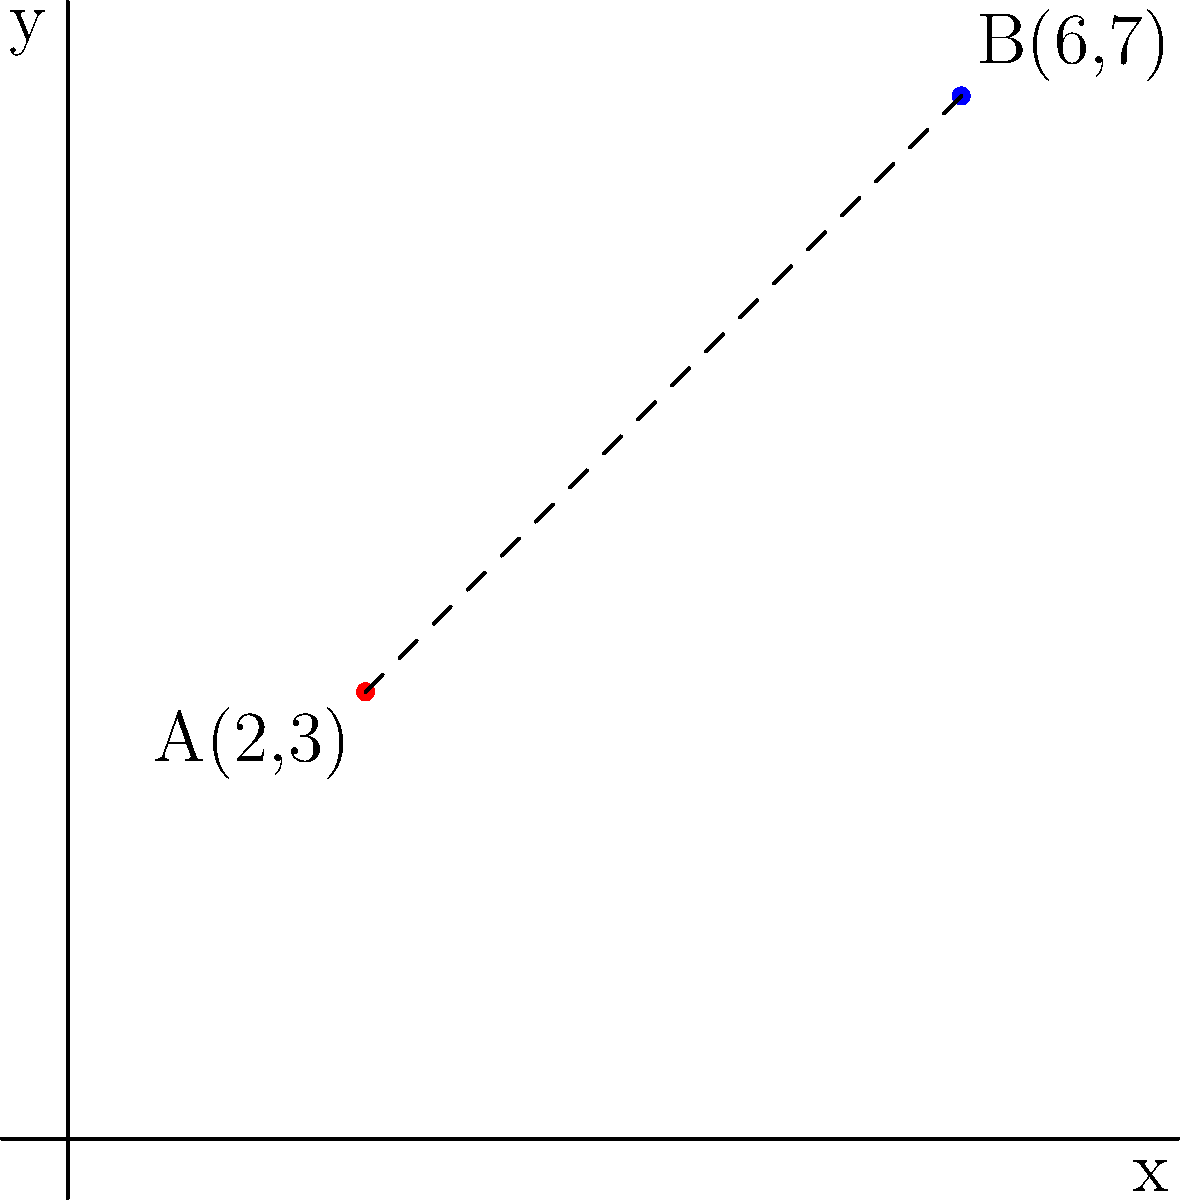Hey there! Remember when we used to solve math problems together back in the day? I've got one that reminds me of Luka. Two points on a coordinate plane represent the locations of his favorite coffee shop (A) and his new apartment (B). If A is at (2,3) and B is at (6,7), what's the straight-line distance between these two points? Let's approach this step-by-step:

1) We can use the distance formula to solve this problem. The distance formula is derived from the Pythagorean theorem and is given by:

   $$d = \sqrt{(x_2-x_1)^2 + (y_2-y_1)^2}$$

   where $(x_1,y_1)$ is the first point and $(x_2,y_2)$ is the second point.

2) In this case, we have:
   Point A: $(x_1,y_1) = (2,3)$
   Point B: $(x_2,y_2) = (6,7)$

3) Let's substitute these into the formula:

   $$d = \sqrt{(6-2)^2 + (7-3)^2}$$

4) Simplify inside the parentheses:

   $$d = \sqrt{4^2 + 4^2}$$

5) Calculate the squares:

   $$d = \sqrt{16 + 16}$$

6) Add inside the square root:

   $$d = \sqrt{32}$$

7) Simplify the square root:

   $$d = 4\sqrt{2}$$

Thus, the distance between Luka's favorite coffee shop and his new apartment is $4\sqrt{2}$ units.
Answer: $4\sqrt{2}$ units 